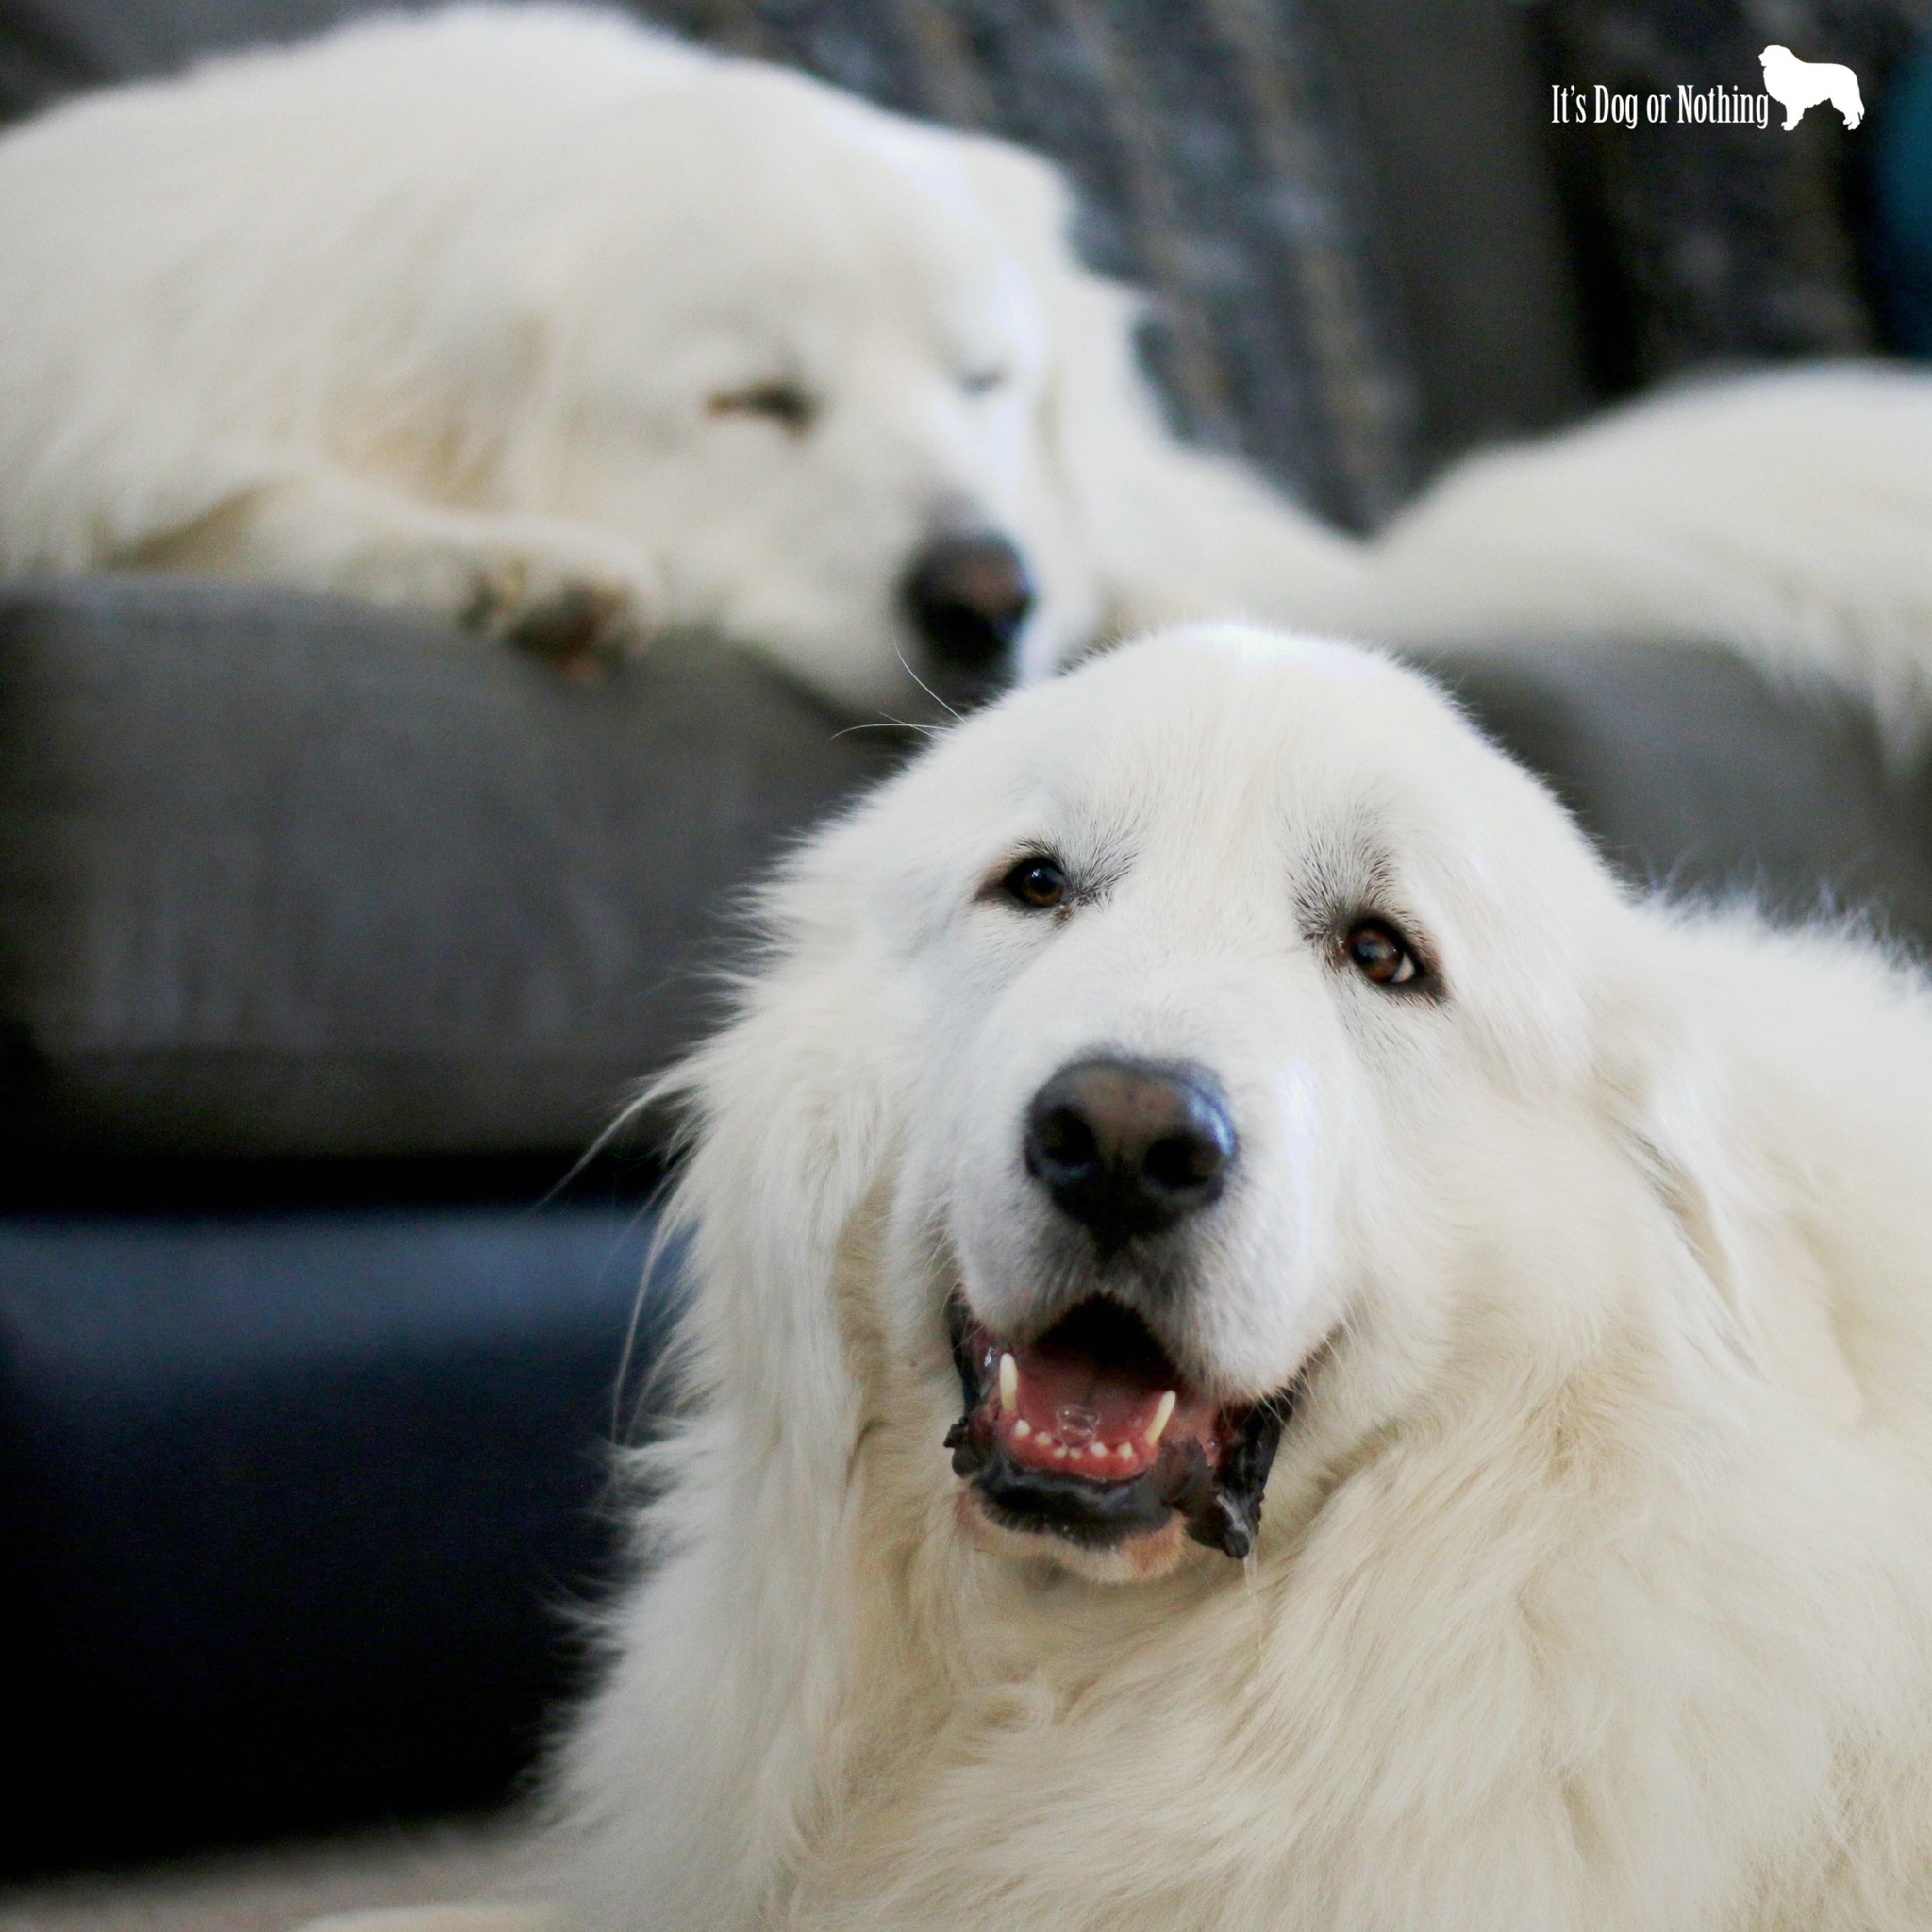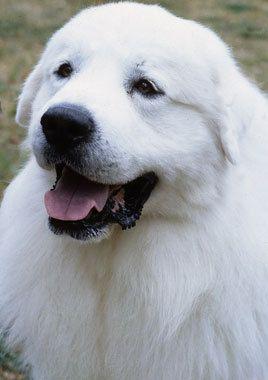The first image is the image on the left, the second image is the image on the right. Given the left and right images, does the statement "there is one dog in the left side pic" hold true? Answer yes or no. No. The first image is the image on the left, the second image is the image on the right. For the images shown, is this caption "There are exactly two dogs." true? Answer yes or no. No. 